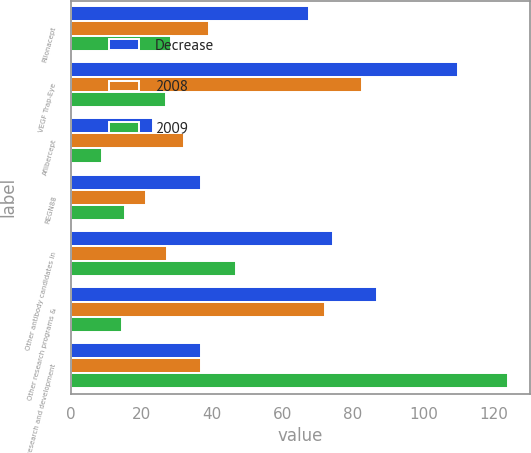<chart> <loc_0><loc_0><loc_500><loc_500><stacked_bar_chart><ecel><fcel>Rilonacept<fcel>VEGF Trap-Eye<fcel>Aflibercept<fcel>REGN88<fcel>Other antibody candidates in<fcel>Other research programs &<fcel>Total research and development<nl><fcel>Decrease<fcel>67.7<fcel>109.8<fcel>23.3<fcel>36.9<fcel>74.4<fcel>86.7<fcel>36.9<nl><fcel>2008<fcel>39.2<fcel>82.7<fcel>32.1<fcel>21.4<fcel>27.4<fcel>72.1<fcel>36.9<nl><fcel>2009<fcel>28.5<fcel>27.1<fcel>8.8<fcel>15.5<fcel>47<fcel>14.6<fcel>123.9<nl></chart> 